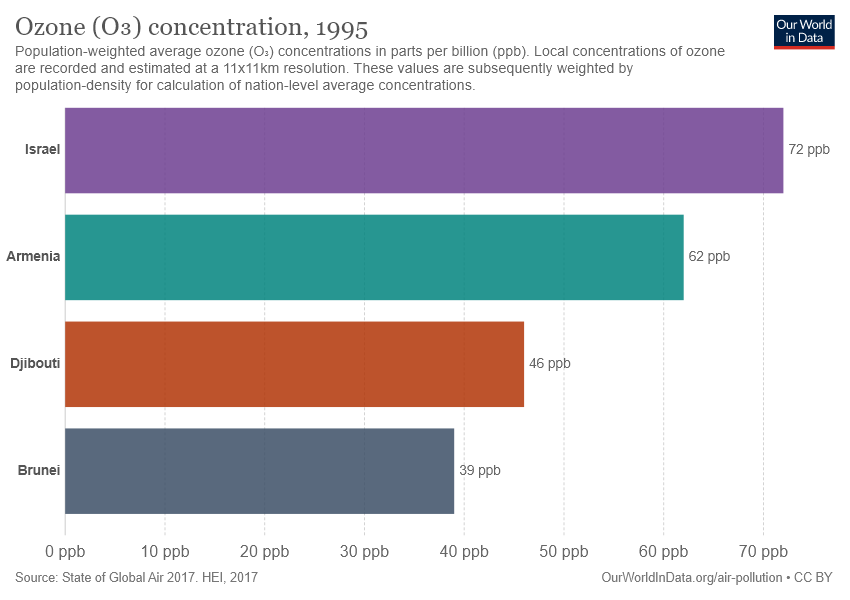Highlight a few significant elements in this photo. There are 4 bars in the chart. The smallest two bars are 7.. 